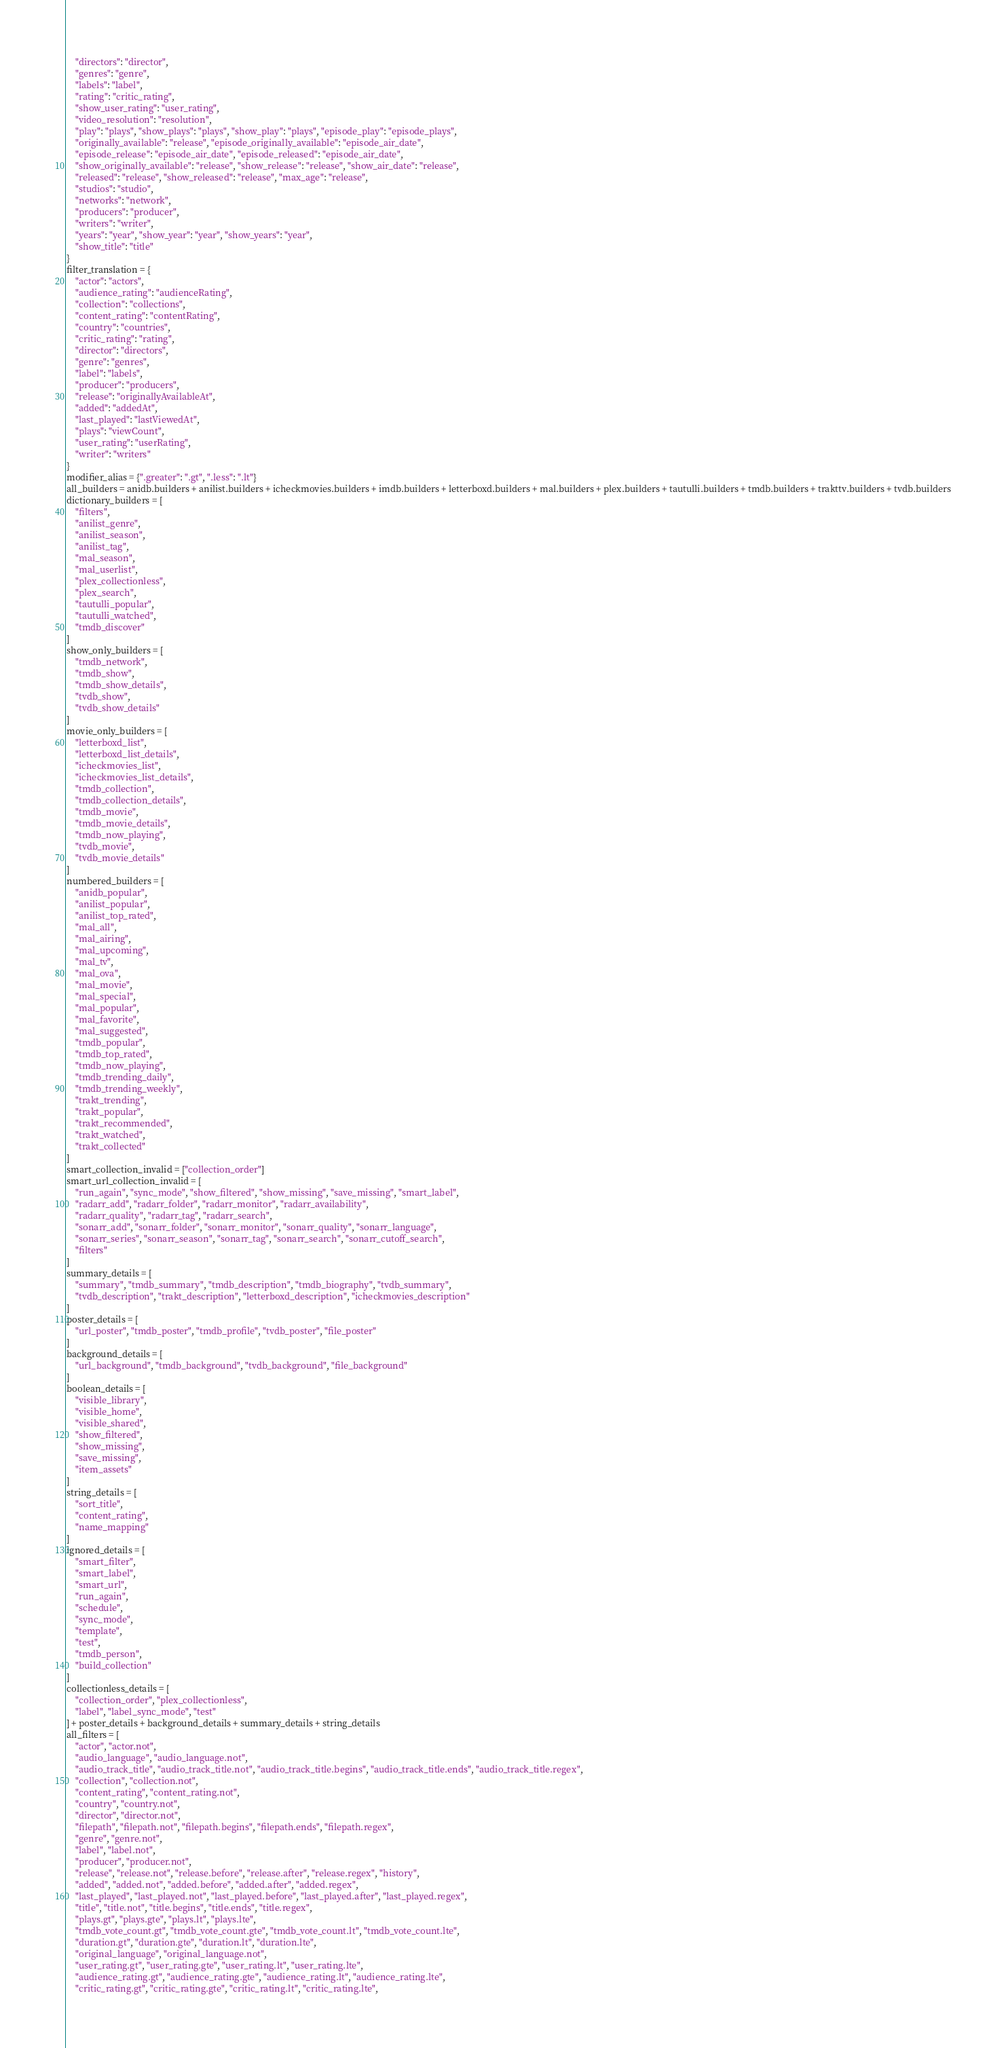<code> <loc_0><loc_0><loc_500><loc_500><_Python_>    "directors": "director",
    "genres": "genre",
    "labels": "label",
    "rating": "critic_rating",
    "show_user_rating": "user_rating",
    "video_resolution": "resolution",
    "play": "plays", "show_plays": "plays", "show_play": "plays", "episode_play": "episode_plays",
    "originally_available": "release", "episode_originally_available": "episode_air_date",
    "episode_release": "episode_air_date", "episode_released": "episode_air_date",
    "show_originally_available": "release", "show_release": "release", "show_air_date": "release",
    "released": "release", "show_released": "release", "max_age": "release",
    "studios": "studio",
    "networks": "network",
    "producers": "producer",
    "writers": "writer",
    "years": "year", "show_year": "year", "show_years": "year",
    "show_title": "title"
}
filter_translation = {
    "actor": "actors",
    "audience_rating": "audienceRating",
    "collection": "collections",
    "content_rating": "contentRating",
    "country": "countries",
    "critic_rating": "rating",
    "director": "directors",
    "genre": "genres",
    "label": "labels",
    "producer": "producers",
    "release": "originallyAvailableAt",
    "added": "addedAt",
    "last_played": "lastViewedAt",
    "plays": "viewCount",
    "user_rating": "userRating",
    "writer": "writers"
}
modifier_alias = {".greater": ".gt", ".less": ".lt"}
all_builders = anidb.builders + anilist.builders + icheckmovies.builders + imdb.builders + letterboxd.builders + mal.builders + plex.builders + tautulli.builders + tmdb.builders + trakttv.builders + tvdb.builders
dictionary_builders = [
    "filters",
    "anilist_genre",
    "anilist_season",
    "anilist_tag",
    "mal_season",
    "mal_userlist",
    "plex_collectionless",
    "plex_search",
    "tautulli_popular",
    "tautulli_watched",
    "tmdb_discover"
]
show_only_builders = [
    "tmdb_network",
    "tmdb_show",
    "tmdb_show_details",
    "tvdb_show",
    "tvdb_show_details"
]
movie_only_builders = [
    "letterboxd_list",
    "letterboxd_list_details",
    "icheckmovies_list",
    "icheckmovies_list_details",
    "tmdb_collection",
    "tmdb_collection_details",
    "tmdb_movie",
    "tmdb_movie_details",
    "tmdb_now_playing",
    "tvdb_movie",
    "tvdb_movie_details"
]
numbered_builders = [
    "anidb_popular",
    "anilist_popular",
    "anilist_top_rated",
    "mal_all",
    "mal_airing",
    "mal_upcoming",
    "mal_tv",
    "mal_ova",
    "mal_movie",
    "mal_special",
    "mal_popular",
    "mal_favorite",
    "mal_suggested",
    "tmdb_popular",
    "tmdb_top_rated",
    "tmdb_now_playing",
    "tmdb_trending_daily",
    "tmdb_trending_weekly",
    "trakt_trending",
    "trakt_popular",
    "trakt_recommended",
    "trakt_watched",
    "trakt_collected"
]
smart_collection_invalid = ["collection_order"]
smart_url_collection_invalid = [
    "run_again", "sync_mode", "show_filtered", "show_missing", "save_missing", "smart_label",
    "radarr_add", "radarr_folder", "radarr_monitor", "radarr_availability", 
    "radarr_quality", "radarr_tag", "radarr_search",
    "sonarr_add", "sonarr_folder", "sonarr_monitor", "sonarr_quality", "sonarr_language", 
    "sonarr_series", "sonarr_season", "sonarr_tag", "sonarr_search", "sonarr_cutoff_search",
    "filters"
]
summary_details = [
    "summary", "tmdb_summary", "tmdb_description", "tmdb_biography", "tvdb_summary",
    "tvdb_description", "trakt_description", "letterboxd_description", "icheckmovies_description"
]
poster_details = [
    "url_poster", "tmdb_poster", "tmdb_profile", "tvdb_poster", "file_poster"
]
background_details = [
    "url_background", "tmdb_background", "tvdb_background", "file_background"
]
boolean_details = [
    "visible_library",
    "visible_home",
    "visible_shared",
    "show_filtered",
    "show_missing",
    "save_missing",
    "item_assets"
]
string_details = [
    "sort_title",
    "content_rating",
    "name_mapping"
]
ignored_details = [
    "smart_filter",
    "smart_label",
    "smart_url",
    "run_again",
    "schedule",
    "sync_mode",
    "template",
    "test",
    "tmdb_person",
    "build_collection"
]
collectionless_details = [
    "collection_order", "plex_collectionless",
    "label", "label_sync_mode", "test"
] + poster_details + background_details + summary_details + string_details
all_filters = [
    "actor", "actor.not",
    "audio_language", "audio_language.not",
    "audio_track_title", "audio_track_title.not", "audio_track_title.begins", "audio_track_title.ends", "audio_track_title.regex",
    "collection", "collection.not",
    "content_rating", "content_rating.not",
    "country", "country.not",
    "director", "director.not",
    "filepath", "filepath.not", "filepath.begins", "filepath.ends", "filepath.regex",
    "genre", "genre.not",
    "label", "label.not",
    "producer", "producer.not",
    "release", "release.not", "release.before", "release.after", "release.regex", "history",
    "added", "added.not", "added.before", "added.after", "added.regex",
    "last_played", "last_played.not", "last_played.before", "last_played.after", "last_played.regex",
    "title", "title.not", "title.begins", "title.ends", "title.regex",
    "plays.gt", "plays.gte", "plays.lt", "plays.lte",
    "tmdb_vote_count.gt", "tmdb_vote_count.gte", "tmdb_vote_count.lt", "tmdb_vote_count.lte",
    "duration.gt", "duration.gte", "duration.lt", "duration.lte",
    "original_language", "original_language.not",
    "user_rating.gt", "user_rating.gte", "user_rating.lt", "user_rating.lte",
    "audience_rating.gt", "audience_rating.gte", "audience_rating.lt", "audience_rating.lte",
    "critic_rating.gt", "critic_rating.gte", "critic_rating.lt", "critic_rating.lte",</code> 